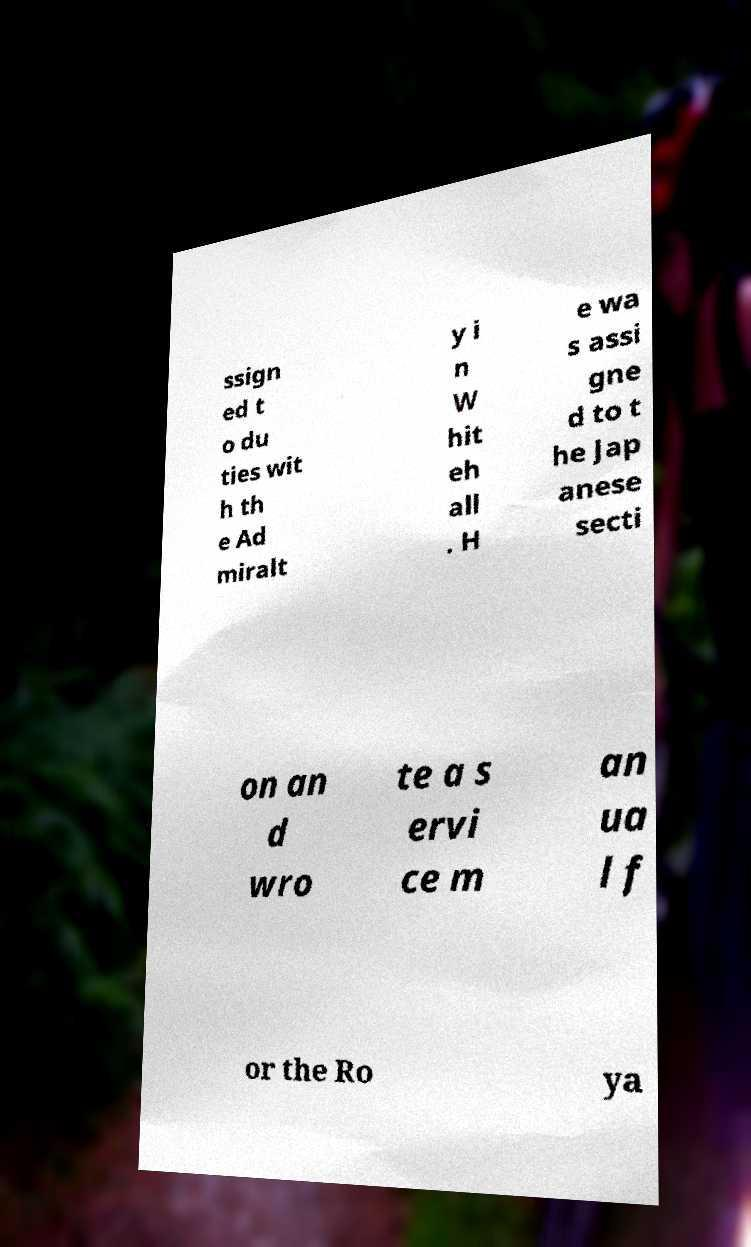Can you read and provide the text displayed in the image?This photo seems to have some interesting text. Can you extract and type it out for me? ssign ed t o du ties wit h th e Ad miralt y i n W hit eh all . H e wa s assi gne d to t he Jap anese secti on an d wro te a s ervi ce m an ua l f or the Ro ya 